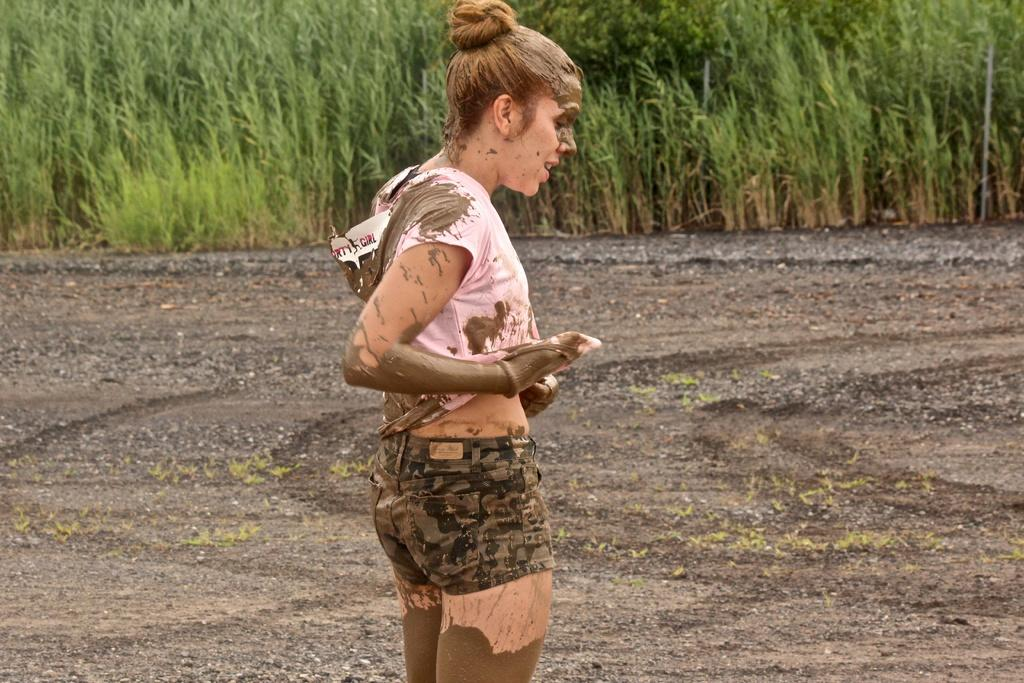What is the main subject of the image? The main subject of the image is a person standing. What is the person standing on? The person is standing on the ground. What type of vegetation can be seen in the image? There are plants and trees visible in the image. Is the person in the image sleeping or part of an army? The image does not provide any information about the person's state of sleep or their involvement with an army. Can you see any signs of the plants or trees being burned in the image? There is no indication of any plants or trees being burned in the image. 